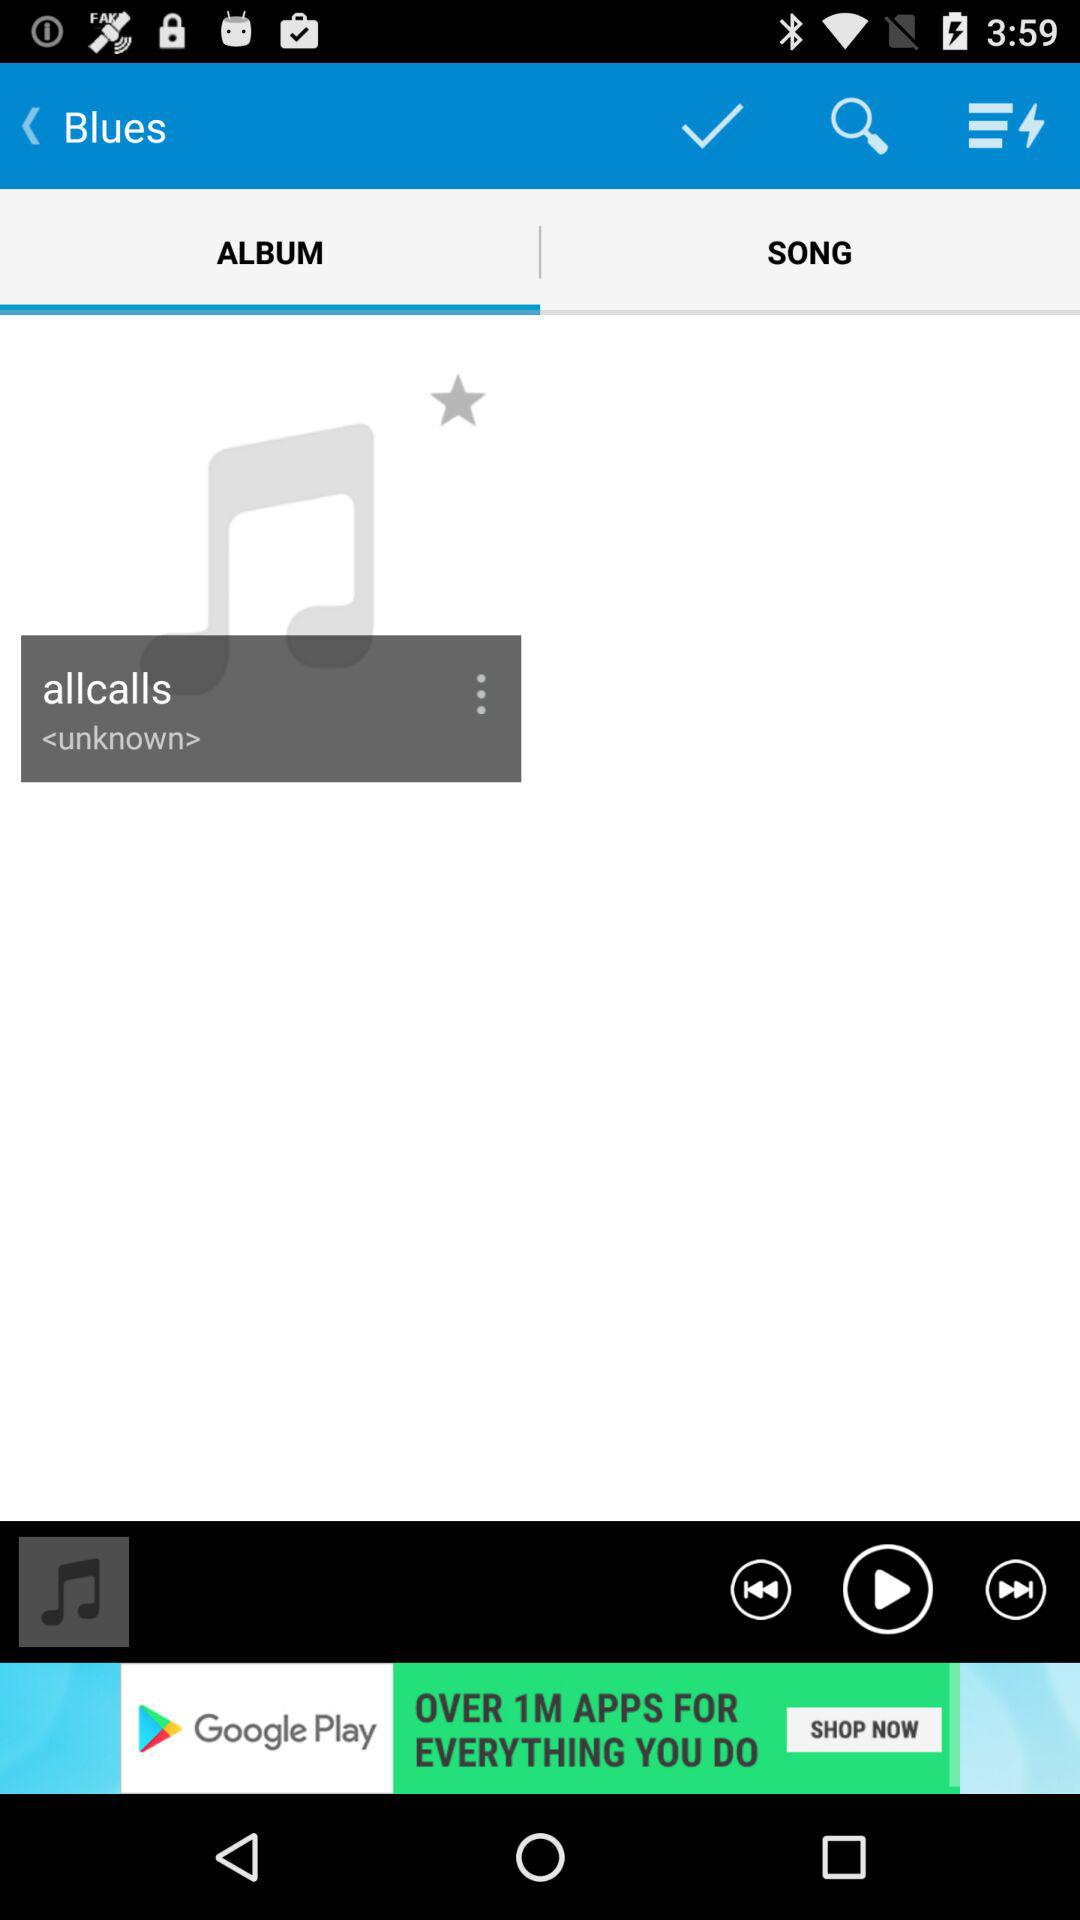Which tab has been selected? The tab that has been selected is "ALBUM". 